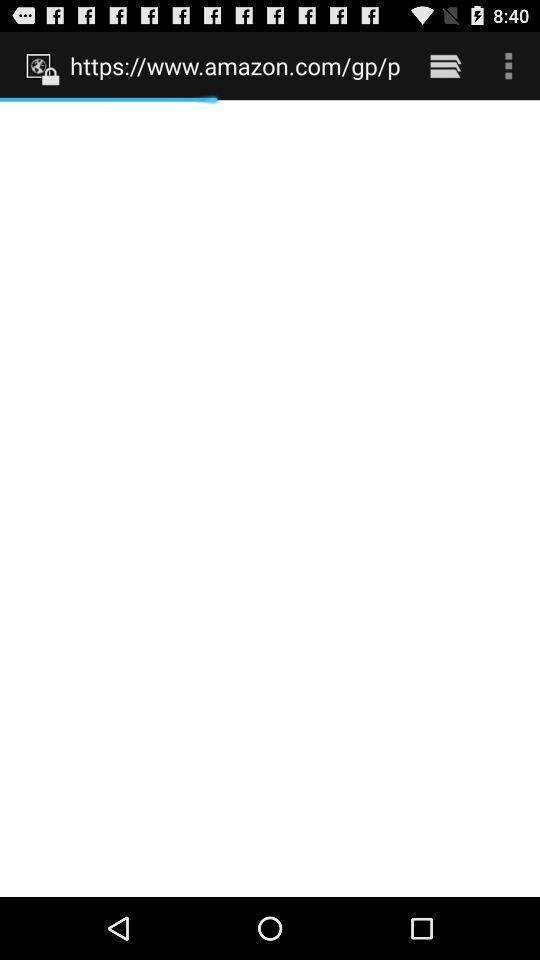Provide a textual representation of this image. Page with loading related to a reminder app. 